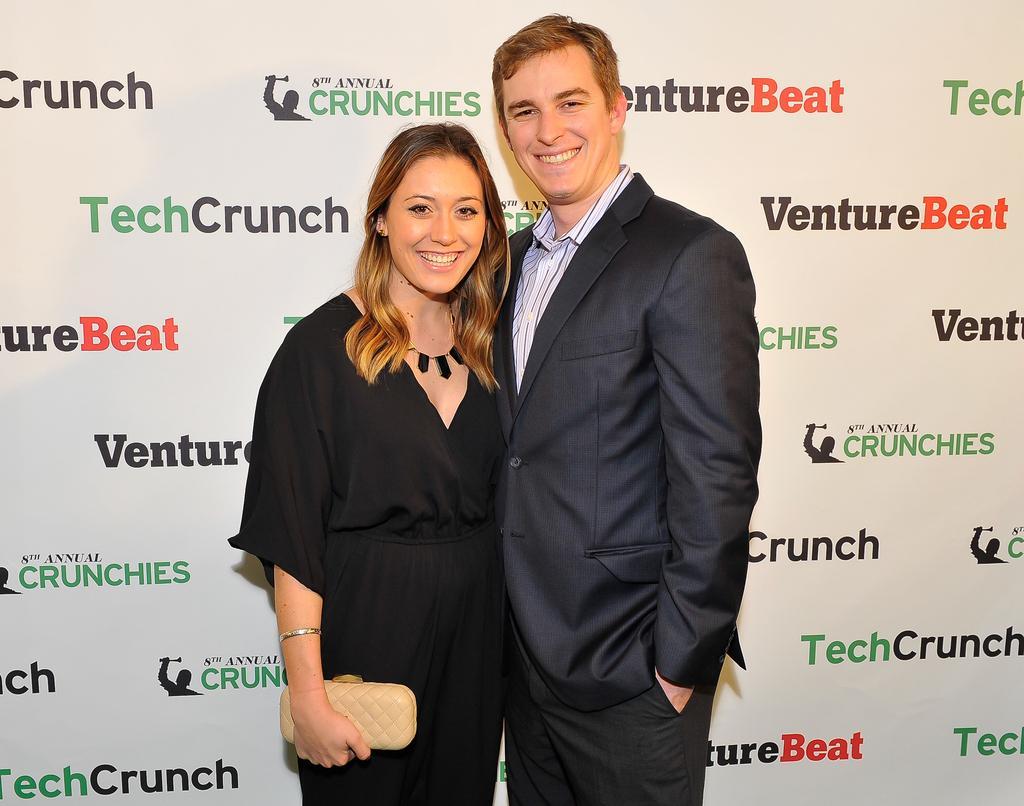How would you summarize this image in a sentence or two? In this image I can see a woman wearing black dress is standing and holding a cream colored object in her hand and a person wearing white shirt, black blazer and black pant is standing beside her. In the background I can see the white colored banner and few words written on it. 